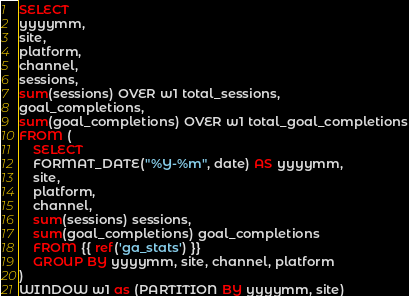<code> <loc_0><loc_0><loc_500><loc_500><_SQL_>SELECT
yyyymm, 
site,
platform,
channel, 
sessions,
sum(sessions) OVER w1 total_sessions,
goal_completions,
sum(goal_completions) OVER w1 total_goal_completions
FROM (
    SELECT 
    FORMAT_DATE("%Y-%m", date) AS yyyymm,
    site,
    platform,
    channel, 
    sum(sessions) sessions,
    sum(goal_completions) goal_completions
    FROM {{ ref('ga_stats') }}
    GROUP BY yyyymm, site, channel, platform
)
WINDOW w1 as (PARTITION BY yyyymm, site)</code> 